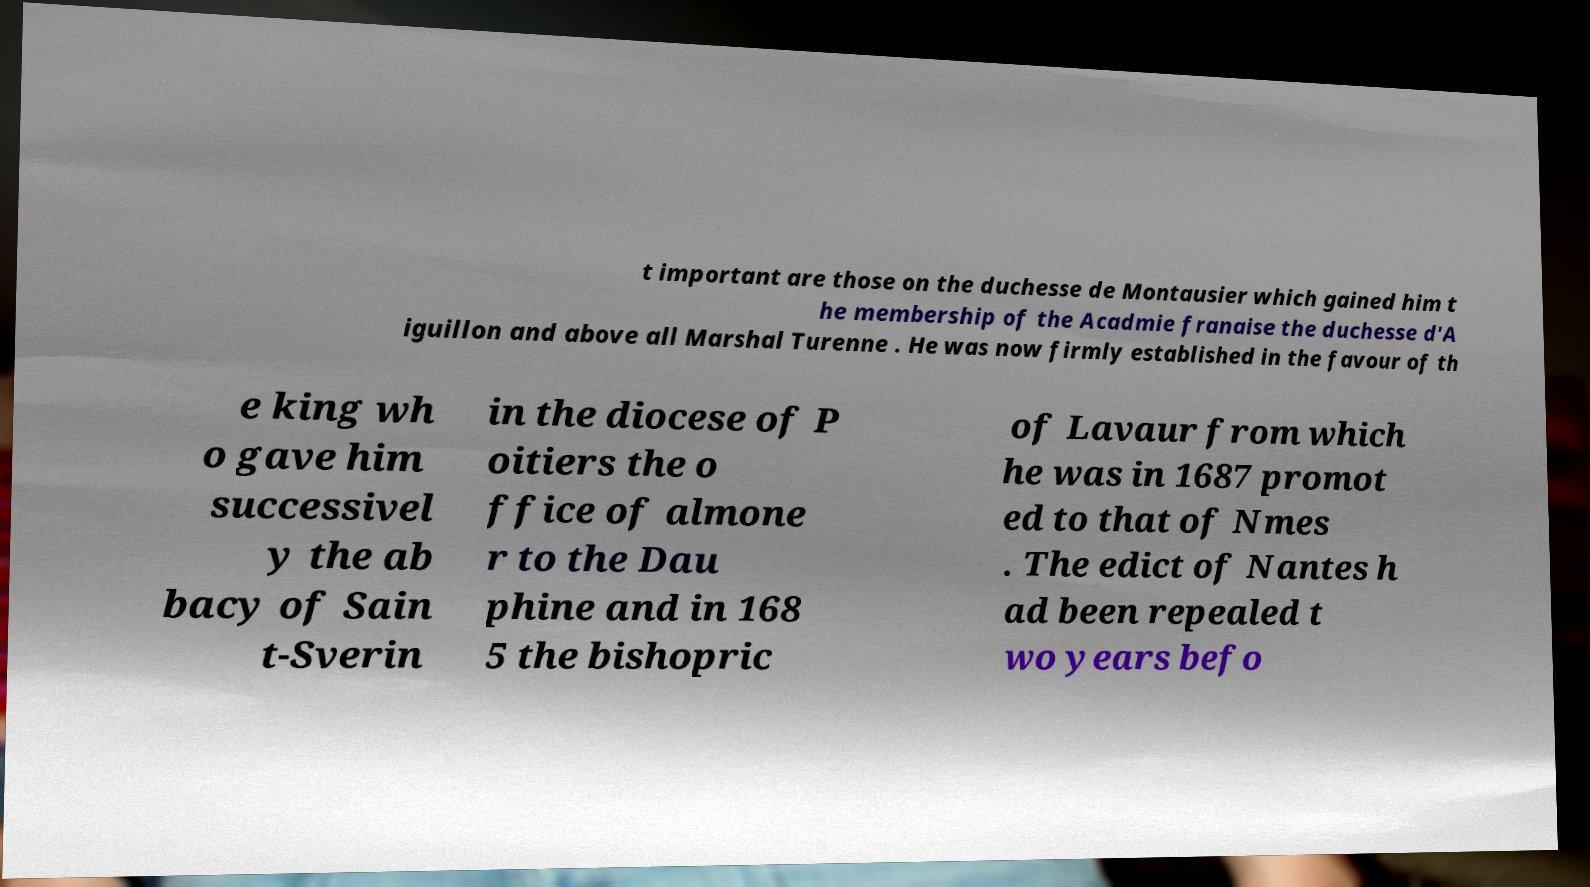What messages or text are displayed in this image? I need them in a readable, typed format. t important are those on the duchesse de Montausier which gained him t he membership of the Acadmie franaise the duchesse d'A iguillon and above all Marshal Turenne . He was now firmly established in the favour of th e king wh o gave him successivel y the ab bacy of Sain t-Sverin in the diocese of P oitiers the o ffice of almone r to the Dau phine and in 168 5 the bishopric of Lavaur from which he was in 1687 promot ed to that of Nmes . The edict of Nantes h ad been repealed t wo years befo 